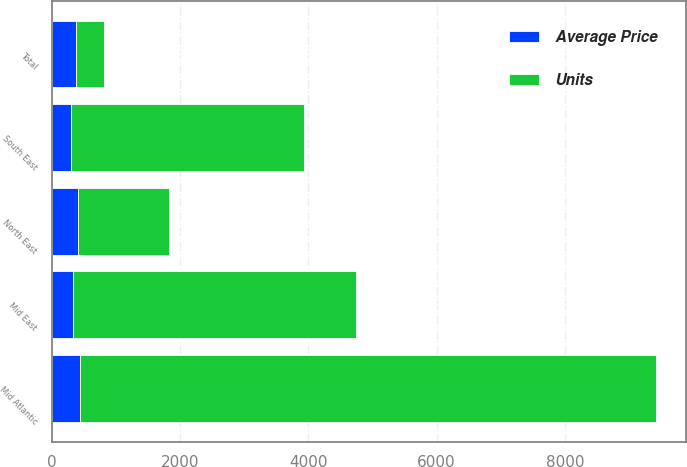<chart> <loc_0><loc_0><loc_500><loc_500><stacked_bar_chart><ecel><fcel>Mid Atlantic<fcel>North East<fcel>Mid East<fcel>South East<fcel>Total<nl><fcel>Units<fcel>8982<fcel>1415<fcel>4406<fcel>3644<fcel>433.4<nl><fcel>Average Price<fcel>433.4<fcel>410.4<fcel>330.4<fcel>294.8<fcel>379.7<nl></chart> 